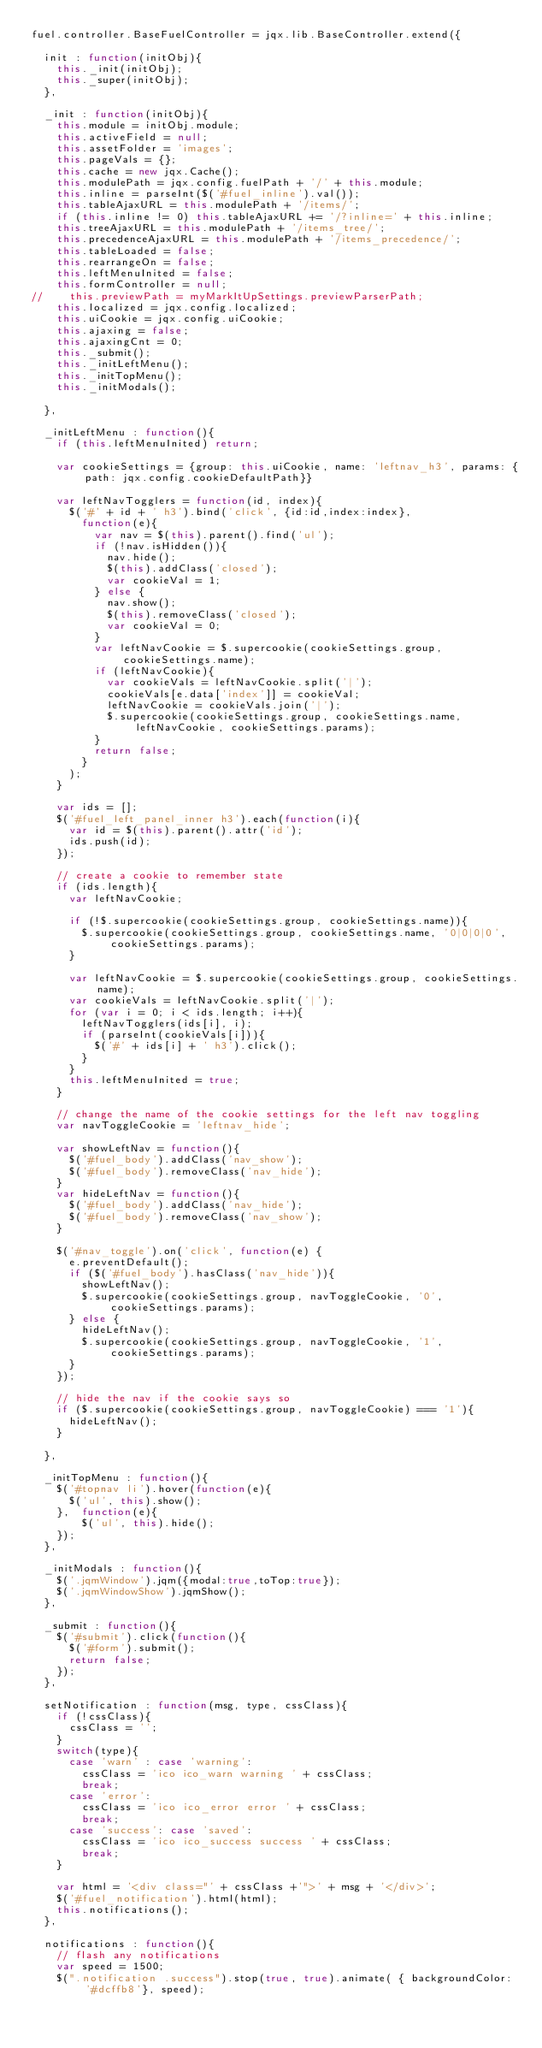Convert code to text. <code><loc_0><loc_0><loc_500><loc_500><_JavaScript_>fuel.controller.BaseFuelController = jqx.lib.BaseController.extend({
	
	init : function(initObj){
		this._init(initObj);
		this._super(initObj);
	},
	
	_init : function(initObj){
		this.module = initObj.module;
		this.activeField = null;
		this.assetFolder = 'images';
		this.pageVals = {};
		this.cache = new jqx.Cache();
		this.modulePath = jqx.config.fuelPath + '/' + this.module;
		this.inline = parseInt($('#fuel_inline').val());
		this.tableAjaxURL = this.modulePath + '/items/';
		if (this.inline != 0) this.tableAjaxURL += '/?inline=' + this.inline;
		this.treeAjaxURL = this.modulePath + '/items_tree/';
		this.precedenceAjaxURL = this.modulePath + '/items_precedence/';
		this.tableLoaded = false;
		this.rearrangeOn = false;
		this.leftMenuInited = false;
		this.formController = null;
//		this.previewPath = myMarkItUpSettings.previewParserPath;
		this.localized = jqx.config.localized;
		this.uiCookie = jqx.config.uiCookie;
		this.ajaxing = false;
		this.ajaxingCnt = 0;
		this._submit();
		this._initLeftMenu();
		this._initTopMenu();
		this._initModals();

	},
	
	_initLeftMenu : function(){
		if (this.leftMenuInited) return;

		var cookieSettings = {group: this.uiCookie, name: 'leftnav_h3', params: {path: jqx.config.cookieDefaultPath}}

		var leftNavTogglers = function(id, index){
			$('#' + id + ' h3').bind('click', {id:id,index:index},
				function(e){
					var nav = $(this).parent().find('ul');
					if (!nav.isHidden()){
						nav.hide();
						$(this).addClass('closed');
						var cookieVal = 1;
					} else {
						nav.show();
						$(this).removeClass('closed');
						var cookieVal = 0;
					}
					var leftNavCookie = $.supercookie(cookieSettings.group, cookieSettings.name);
					if (leftNavCookie){
						var cookieVals = leftNavCookie.split('|');
						cookieVals[e.data['index']] = cookieVal;
						leftNavCookie = cookieVals.join('|');
						$.supercookie(cookieSettings.group, cookieSettings.name, leftNavCookie, cookieSettings.params);
					}
					return false;
				}
			);
		}
		
		var ids = [];
		$('#fuel_left_panel_inner h3').each(function(i){
			var id = $(this).parent().attr('id');
			ids.push(id);
		});
		
		// create a cookie to remember state
		if (ids.length){
			var leftNavCookie;

			if (!$.supercookie(cookieSettings.group, cookieSettings.name)){
				$.supercookie(cookieSettings.group, cookieSettings.name, '0|0|0|0', cookieSettings.params);
			}

			var leftNavCookie = $.supercookie(cookieSettings.group, cookieSettings.name);
			var cookieVals = leftNavCookie.split('|');
			for (var i = 0; i < ids.length; i++){
				leftNavTogglers(ids[i], i);
				if (parseInt(cookieVals[i])){
					$('#' + ids[i] + ' h3').click();
				}
			}
			this.leftMenuInited = true;
		}
		
		// change the name of the cookie settings for the left nav toggling
		var navToggleCookie = 'leftnav_hide';

		var showLeftNav = function(){
			$('#fuel_body').addClass('nav_show');
			$('#fuel_body').removeClass('nav_hide');
		}
		var hideLeftNav = function(){
			$('#fuel_body').addClass('nav_hide');
			$('#fuel_body').removeClass('nav_show');
		}

		$('#nav_toggle').on('click', function(e) {
			e.preventDefault();
			if ($('#fuel_body').hasClass('nav_hide')){
				showLeftNav();
				$.supercookie(cookieSettings.group, navToggleCookie, '0', cookieSettings.params);
			} else {
				hideLeftNav();
				$.supercookie(cookieSettings.group, navToggleCookie, '1', cookieSettings.params);
			}
		});

		// hide the nav if the cookie says so
		if ($.supercookie(cookieSettings.group, navToggleCookie) === '1'){
			hideLeftNav();	
		}
		
	},
	
	_initTopMenu : function(){
		$('#topnav li').hover(function(e){
			$('ul', this).show();
		}, 	function(e){
				$('ul', this).hide();
		});
	},
	
	_initModals : function(){
		$('.jqmWindow').jqm({modal:true,toTop:true});
		$('.jqmWindowShow').jqmShow();
	},

	_submit : function(){
		$('#submit').click(function(){
			$('#form').submit();
			return false;
		});
	},
	
	setNotification : function(msg, type, cssClass){
		if (!cssClass){
			cssClass = '';
		}
		switch(type){
			case 'warn' : case 'warning':
				cssClass = 'ico ico_warn warning ' + cssClass;
				break;
			case 'error':
				cssClass = 'ico ico_error error ' + cssClass;
				break;
			case 'success': case 'saved':
				cssClass = 'ico ico_success success ' + cssClass;
				break;
		}
		
		var html = '<div class="' + cssClass +'">' + msg + '</div>';
		$('#fuel_notification').html(html);
		this.notifications();
	},
	
	notifications : function(){
		// flash any notifications
		var speed = 1500;
		$(".notification .success").stop(true, true).animate( { backgroundColor: '#dcffb8'}, speed);</code> 